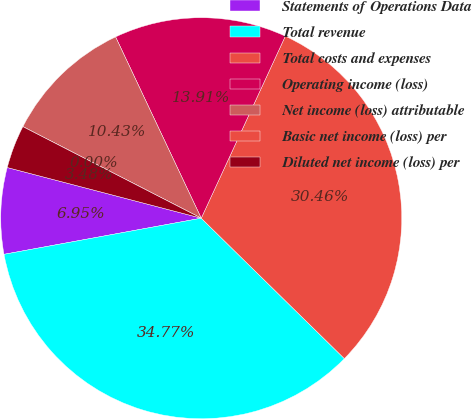Convert chart. <chart><loc_0><loc_0><loc_500><loc_500><pie_chart><fcel>Statements of Operations Data<fcel>Total revenue<fcel>Total costs and expenses<fcel>Operating income (loss)<fcel>Net income (loss) attributable<fcel>Basic net income (loss) per<fcel>Diluted net income (loss) per<nl><fcel>6.95%<fcel>34.77%<fcel>30.46%<fcel>13.91%<fcel>10.43%<fcel>0.0%<fcel>3.48%<nl></chart> 